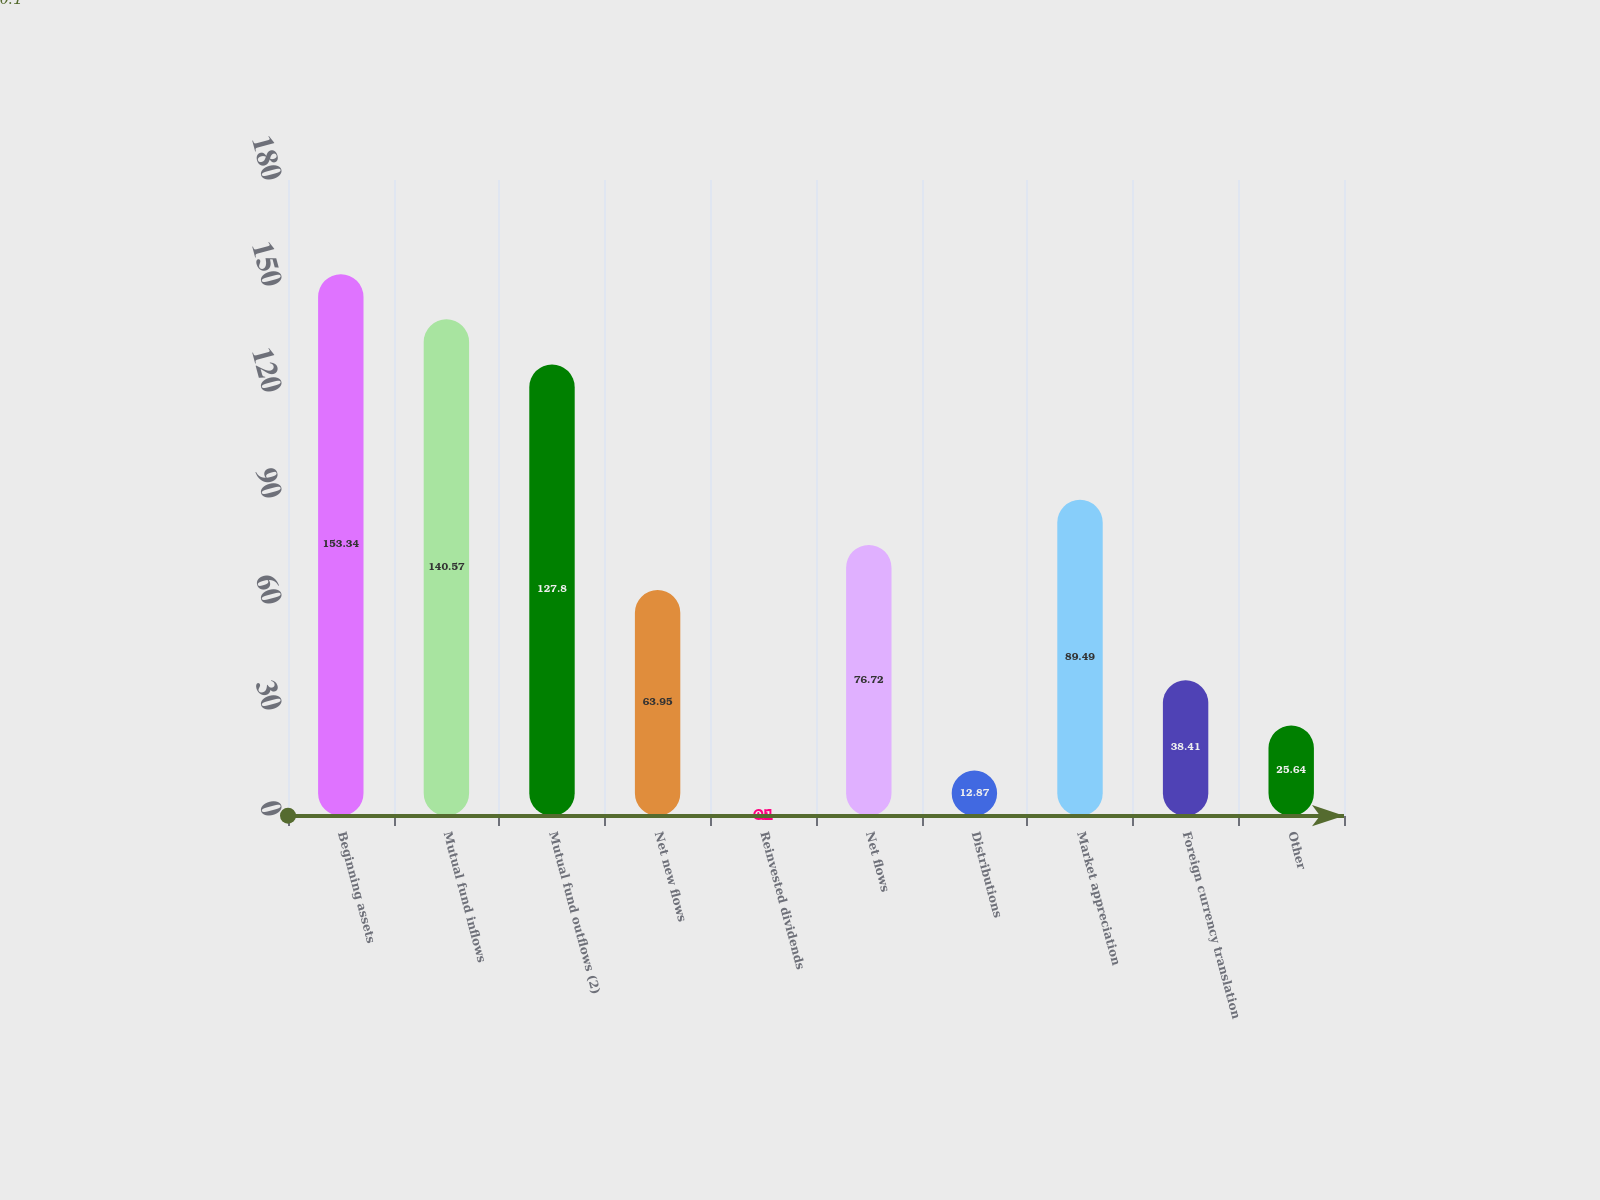Convert chart. <chart><loc_0><loc_0><loc_500><loc_500><bar_chart><fcel>Beginning assets<fcel>Mutual fund inflows<fcel>Mutual fund outflows (2)<fcel>Net new flows<fcel>Reinvested dividends<fcel>Net flows<fcel>Distributions<fcel>Market appreciation<fcel>Foreign currency translation<fcel>Other<nl><fcel>153.34<fcel>140.57<fcel>127.8<fcel>63.95<fcel>0.1<fcel>76.72<fcel>12.87<fcel>89.49<fcel>38.41<fcel>25.64<nl></chart> 